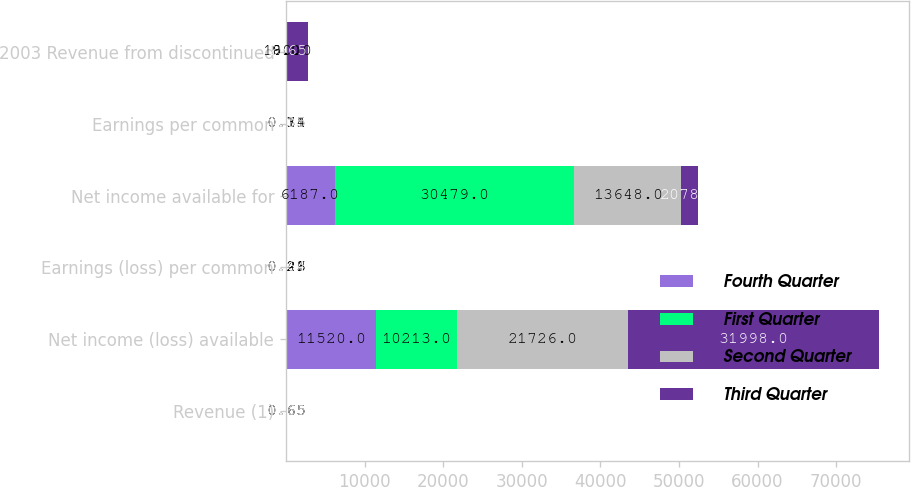Convert chart to OTSL. <chart><loc_0><loc_0><loc_500><loc_500><stacked_bar_chart><ecel><fcel>Revenue (1)<fcel>Net income (loss) available<fcel>Earnings (loss) per common<fcel>Net income available for<fcel>Earnings per common<fcel>2003 Revenue from discontinued<nl><fcel>Fourth Quarter<fcel>0.65<fcel>11520<fcel>0.26<fcel>6187<fcel>0.15<fcel>0<nl><fcel>First Quarter<fcel>0.65<fcel>10213<fcel>0.21<fcel>30479<fcel>0.74<fcel>9<nl><fcel>Second Quarter<fcel>0.65<fcel>21726<fcel>0.43<fcel>13648<fcel>0.31<fcel>180<nl><fcel>Third Quarter<fcel>0.65<fcel>31998<fcel>0.64<fcel>2078<fcel>0.05<fcel>2565<nl></chart> 